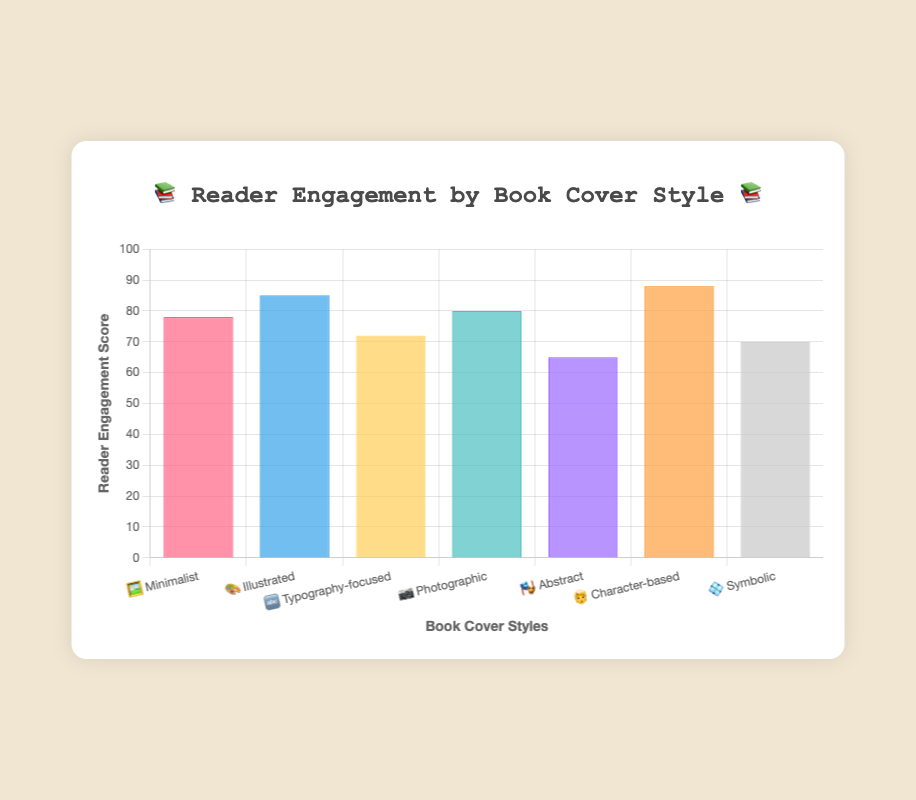What is the reader engagement score for the "Minimalist 🖼️" book cover style? The "Minimalist 🖼️" style has a reader engagement score of 78.
Answer: 78 Which book cover style has the highest reader engagement score? The "Character-based 🧑" style has the highest score of 88.
Answer: Character-based What is the difference in reader engagement between the "Illustrated 🎨" and "Abstract 🎭" cover styles? The score for "Illustrated 🎨" is 85 and for "Abstract 🎭" is 65. The difference is 85 - 65 = 20.
Answer: 20 How many book cover styles have a reader engagement score of 80 or higher? The book cover styles with scores of 80 or higher are "Illustrated 🎨" (85), "Photographic 📷" (80), and "Character-based 🧑" (88). This totals to 3 styles.
Answer: 3 What is the average reader engagement score for all the book cover styles? Sum all scores: 78 + 85 + 72 + 80 + 65 + 88 + 70 = 538. Divide by the number of styles: 538 / 7 ≈ 76.86.
Answer: 76.86 Which book cover style exactly matches the "📚 Reader Engagement by Book Cover Style 📚" title? None of the cover styles directly match the "📚 Reader Engagement by Book Cover Style 📚" title, as it is a summary title, not a specific style.
Answer: None Between the "Typography-focused 🔤" and "Symbolic 💠" cover styles, which has a higher reader engagement score? The "Typography-focused 🔤" style has a score of 72 while the "Symbolic 💠" has a score of 70. Thus, "Typography-focused 🔤" is higher.
Answer: Typography-focused Which book cover style is indicated by the 📷 emoji, and what is its reader engagement score? The 📷 emoji indicates the "Photographic" cover style, which has a reader engagement score of 80.
Answer: Photographic, 80 Calculate the total reader engagement score for "Minimalist 🖼️", "Illustrated 🎨", and "Character-based 🧑" cover styles. The scores are 78 for "Minimalist 🖼️", 85 for "Illustrated 🎨", and 88 for "Character-based 🧑". Total = 78 + 85 + 88 = 251.
Answer: 251 